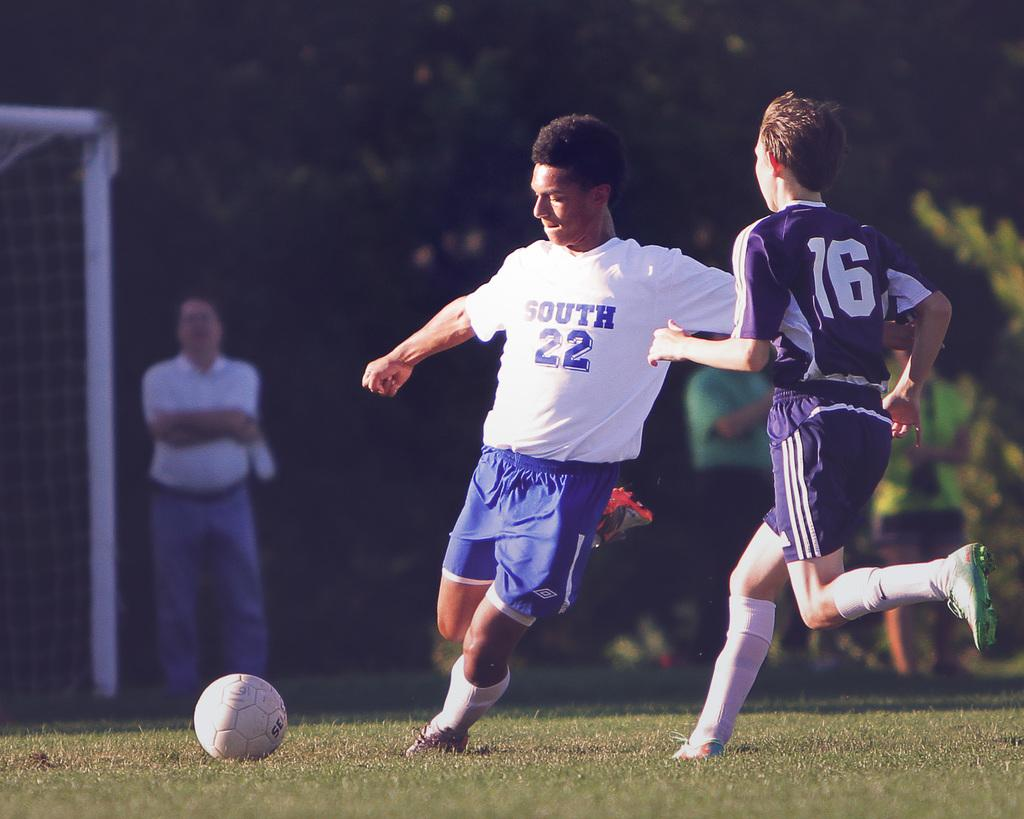<image>
Give a short and clear explanation of the subsequent image. Soccor ball player number 2 and 16 on the field kicking ball 